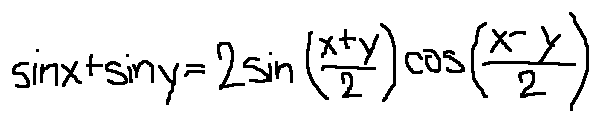Convert formula to latex. <formula><loc_0><loc_0><loc_500><loc_500>\sin x + \sin y = 2 \sin ( \frac { x + y } { 2 } ) \cos ( \frac { x - y } { 2 } )</formula> 